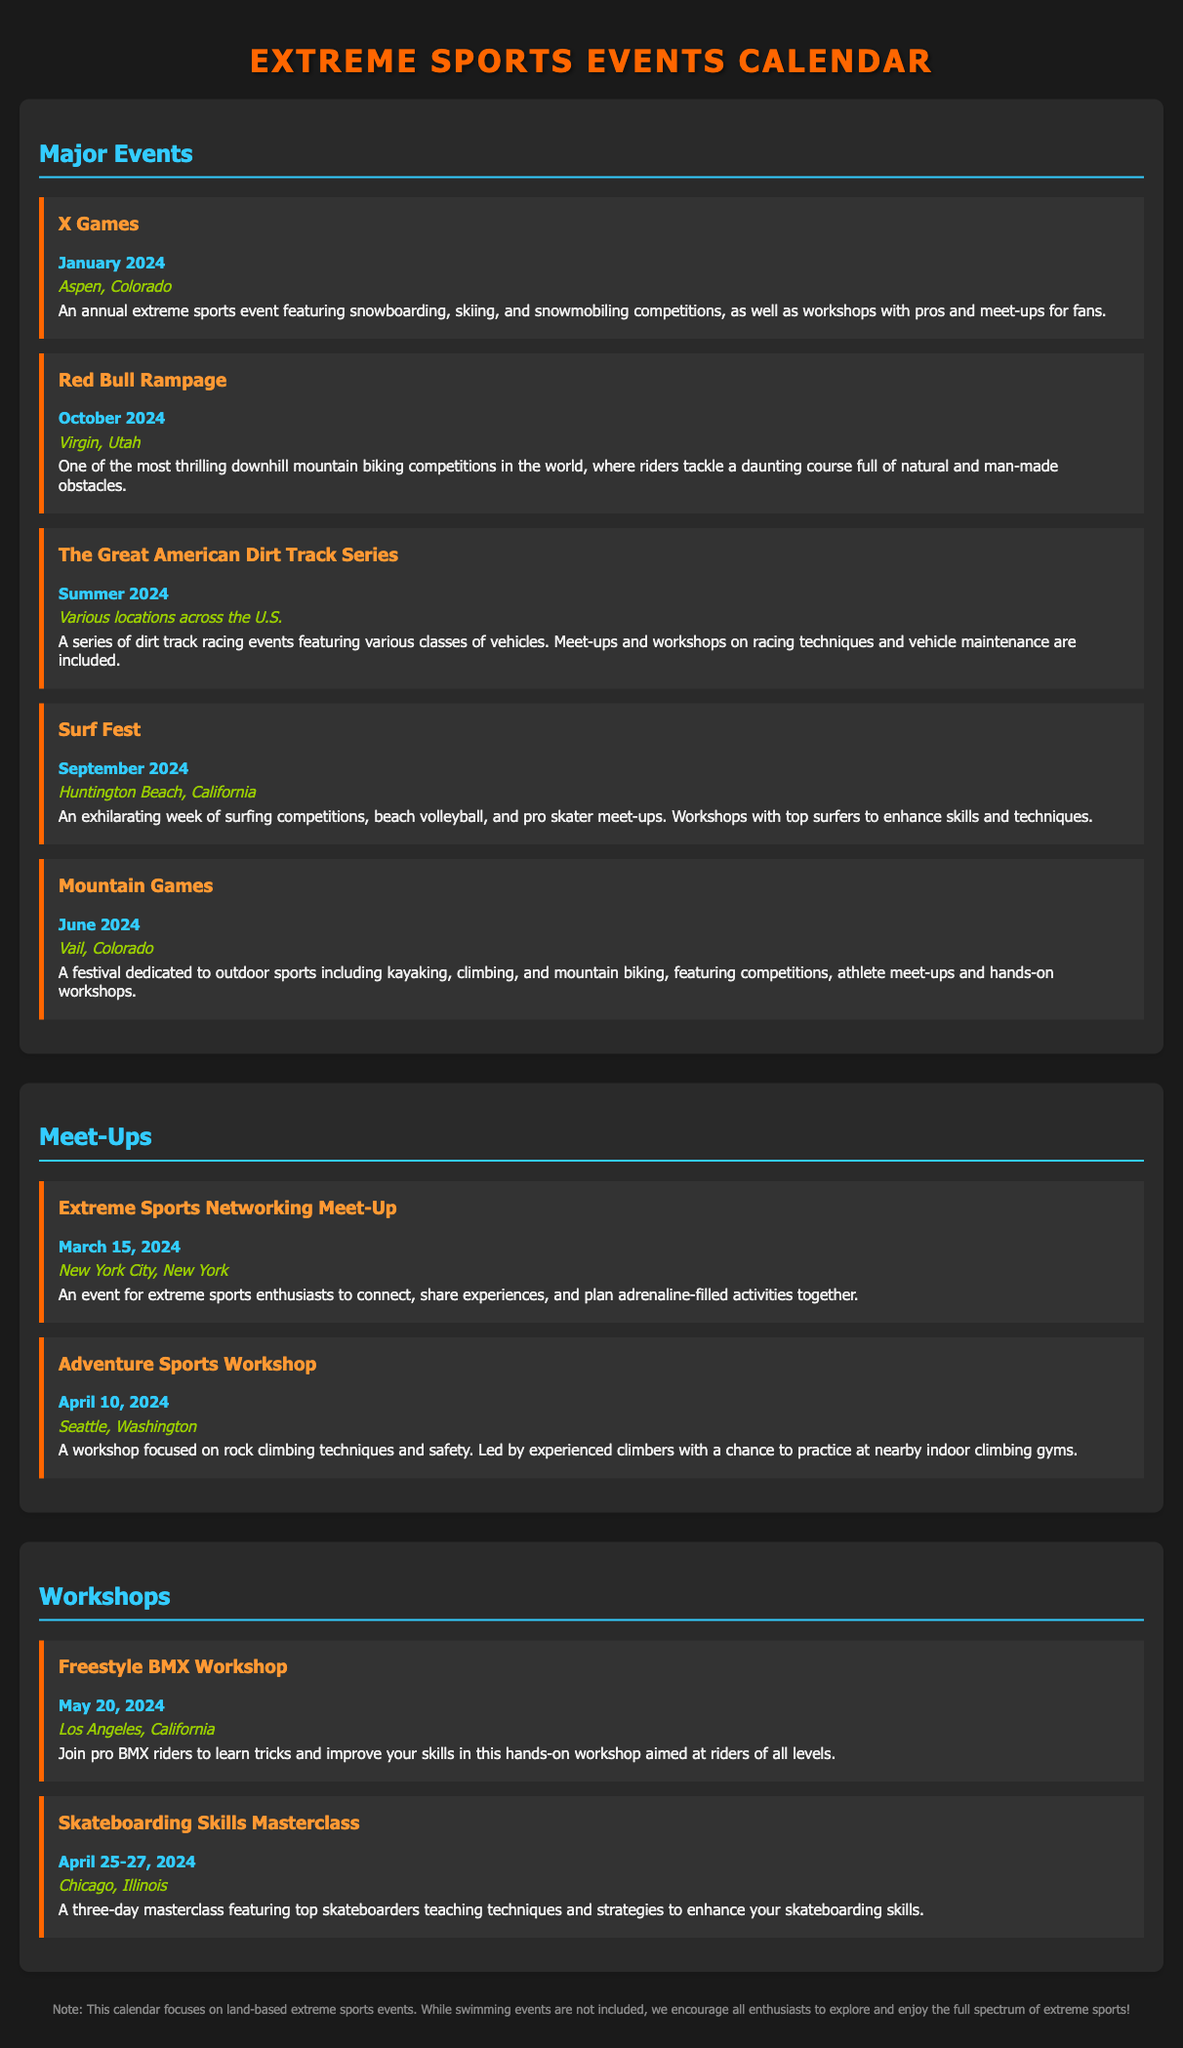What is the date of the X Games? The X Games is scheduled for January 2024, as mentioned in the document.
Answer: January 2024 Where will the Red Bull Rampage take place? The location for the Red Bull Rampage is specified as Virgin, Utah.
Answer: Virgin, Utah What type of event is Surf Fest? Surf Fest includes surfing competitions, beach volleyball, and pro skater meet-ups, highlighting its exhilarating nature.
Answer: Surfing competitions When is the Extreme Sports Networking Meet-Up? The meet-up date is clearly stated as March 15, 2024.
Answer: March 15, 2024 What is the main focus of the Adventure Sports Workshop? The workshop focuses on rock climbing techniques and safety, providing a clear theme.
Answer: Rock climbing techniques How many days is the Skateboarding Skills Masterclass? The document specifies that the masterclass spans three days.
Answer: Three days Which event is mentioned to occur in Summer 2024? The Great American Dirt Track Series is noted to take place in Summer 2024, according to the schedule.
Answer: Summer 2024 What type of event is not included in the calendar? The disclaimer highlights that swimming events are not included in this calendar.
Answer: Swimming events What color is used for the section headings? The section headings are consistently in the color 33ccff throughout the document.
Answer: 33ccff 